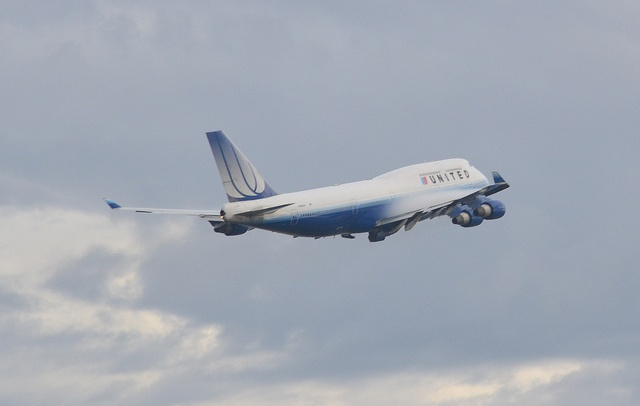Describe the objects in this image and their specific colors. I can see a airplane in darkgray, lightgray, navy, and gray tones in this image. 